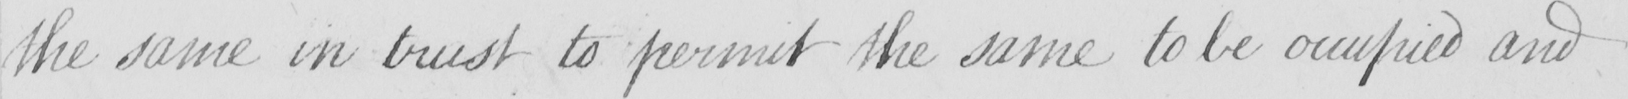Please transcribe the handwritten text in this image. the same in trust to permit the same to be occupied and 